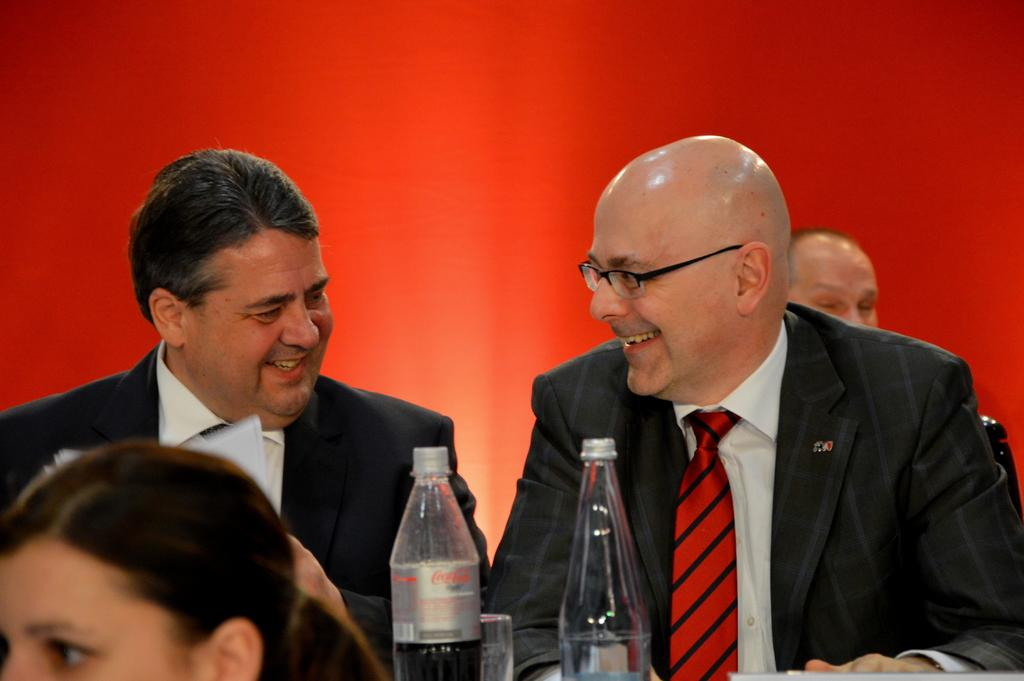How many people are in the image? There are persons in the image, but the exact number is not specified. What color is the background of the image? The background of the image is red. What objects can be seen at the bottom of the image? There are bottles at the bottom of the image. What day of the week is depicted in the image? The day of the week is not mentioned or depicted in the image. How does the grandmother feel in the image? There is no mention of a grandmother in the image, so it is not possible to determine her feelings. 